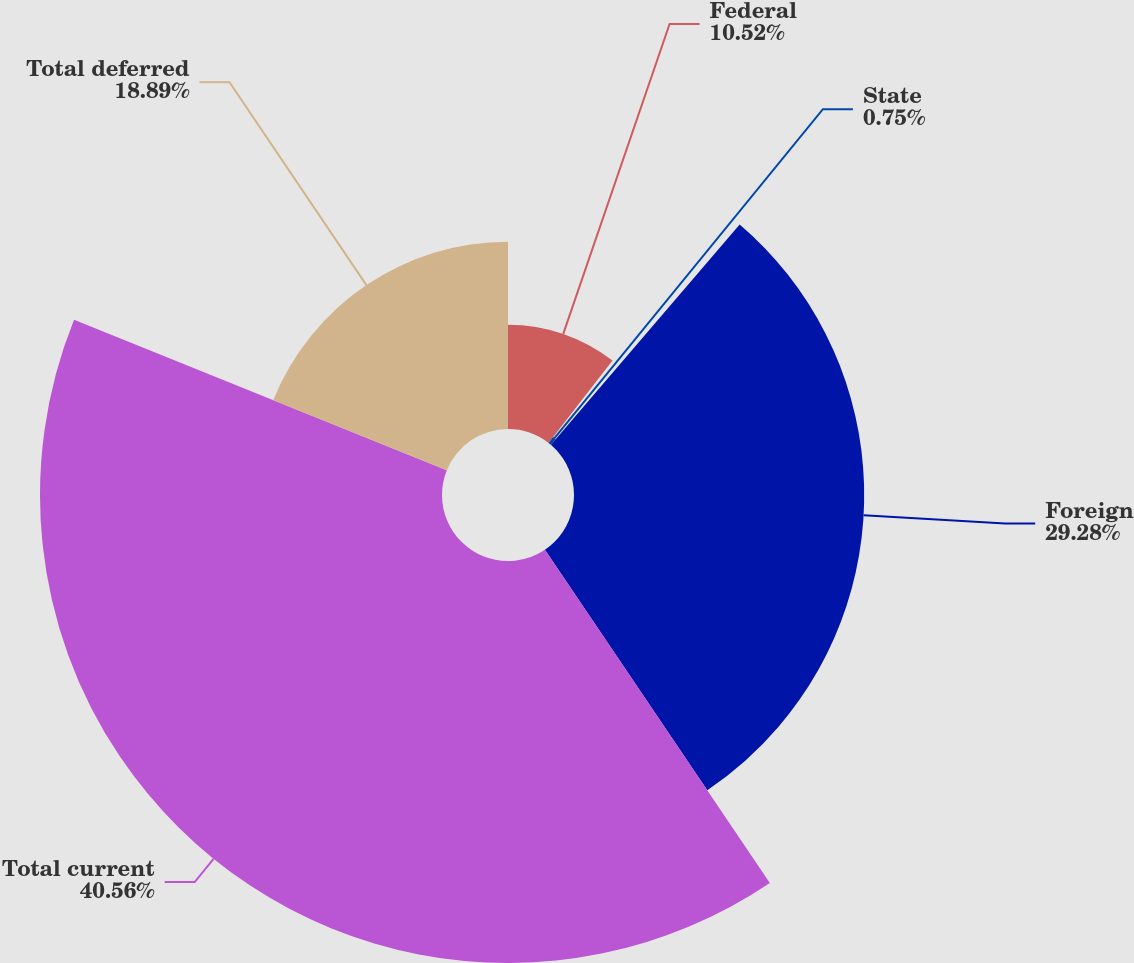<chart> <loc_0><loc_0><loc_500><loc_500><pie_chart><fcel>Federal<fcel>State<fcel>Foreign<fcel>Total current<fcel>Total deferred<nl><fcel>10.52%<fcel>0.75%<fcel>29.28%<fcel>40.56%<fcel>18.89%<nl></chart> 